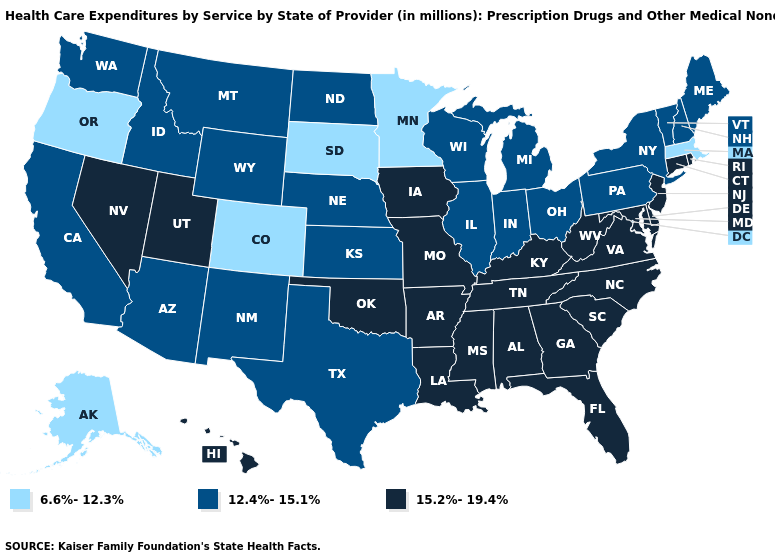What is the value of Massachusetts?
Be succinct. 6.6%-12.3%. What is the value of Illinois?
Answer briefly. 12.4%-15.1%. What is the value of Iowa?
Quick response, please. 15.2%-19.4%. How many symbols are there in the legend?
Be succinct. 3. Among the states that border California , which have the lowest value?
Short answer required. Oregon. Name the states that have a value in the range 12.4%-15.1%?
Give a very brief answer. Arizona, California, Idaho, Illinois, Indiana, Kansas, Maine, Michigan, Montana, Nebraska, New Hampshire, New Mexico, New York, North Dakota, Ohio, Pennsylvania, Texas, Vermont, Washington, Wisconsin, Wyoming. Does the first symbol in the legend represent the smallest category?
Quick response, please. Yes. What is the highest value in states that border Washington?
Write a very short answer. 12.4%-15.1%. Which states have the highest value in the USA?
Be succinct. Alabama, Arkansas, Connecticut, Delaware, Florida, Georgia, Hawaii, Iowa, Kentucky, Louisiana, Maryland, Mississippi, Missouri, Nevada, New Jersey, North Carolina, Oklahoma, Rhode Island, South Carolina, Tennessee, Utah, Virginia, West Virginia. What is the value of Florida?
Concise answer only. 15.2%-19.4%. Which states hav the highest value in the Northeast?
Quick response, please. Connecticut, New Jersey, Rhode Island. What is the value of Texas?
Be succinct. 12.4%-15.1%. Name the states that have a value in the range 15.2%-19.4%?
Write a very short answer. Alabama, Arkansas, Connecticut, Delaware, Florida, Georgia, Hawaii, Iowa, Kentucky, Louisiana, Maryland, Mississippi, Missouri, Nevada, New Jersey, North Carolina, Oklahoma, Rhode Island, South Carolina, Tennessee, Utah, Virginia, West Virginia. Does Delaware have a higher value than Washington?
Give a very brief answer. Yes. What is the lowest value in states that border Michigan?
Concise answer only. 12.4%-15.1%. 